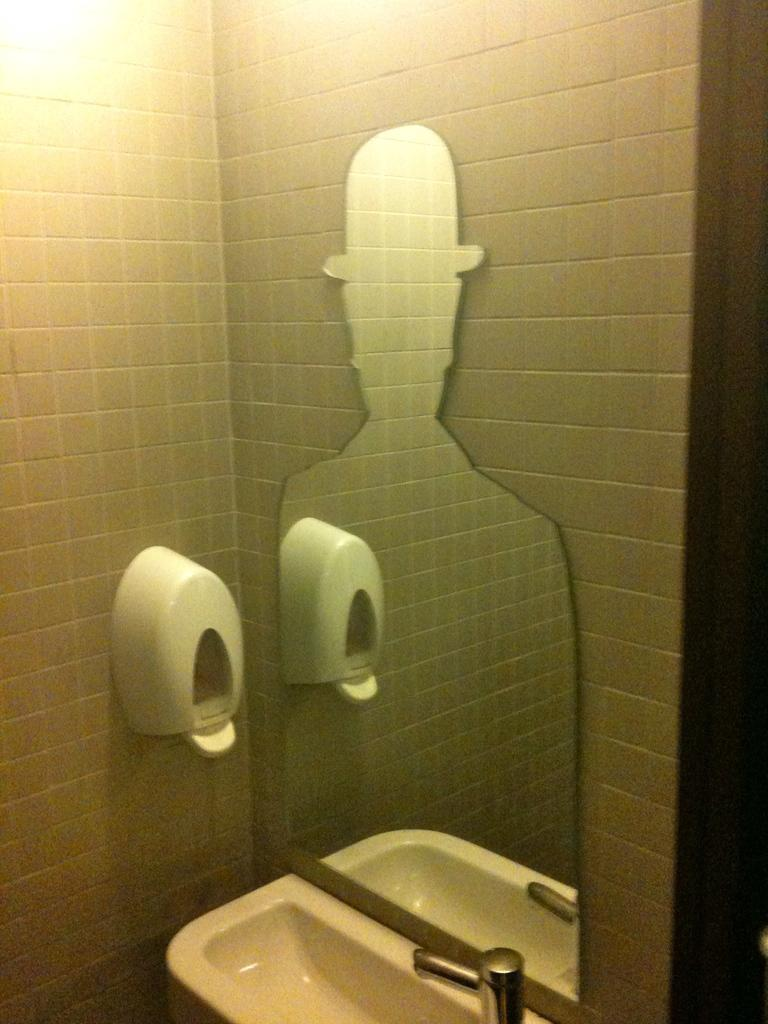What type of equipment is located at the bottom side of the image? There is sanitary equipment at the bottom side of the image. What can be seen on the wall in the center of the image? There is a mirror on the wall in the center of the image. How many chickens are present in the image? There are no chickens present in the image. What is the starting point of the activity in the image? There is no activity or starting point depicted in the image. 